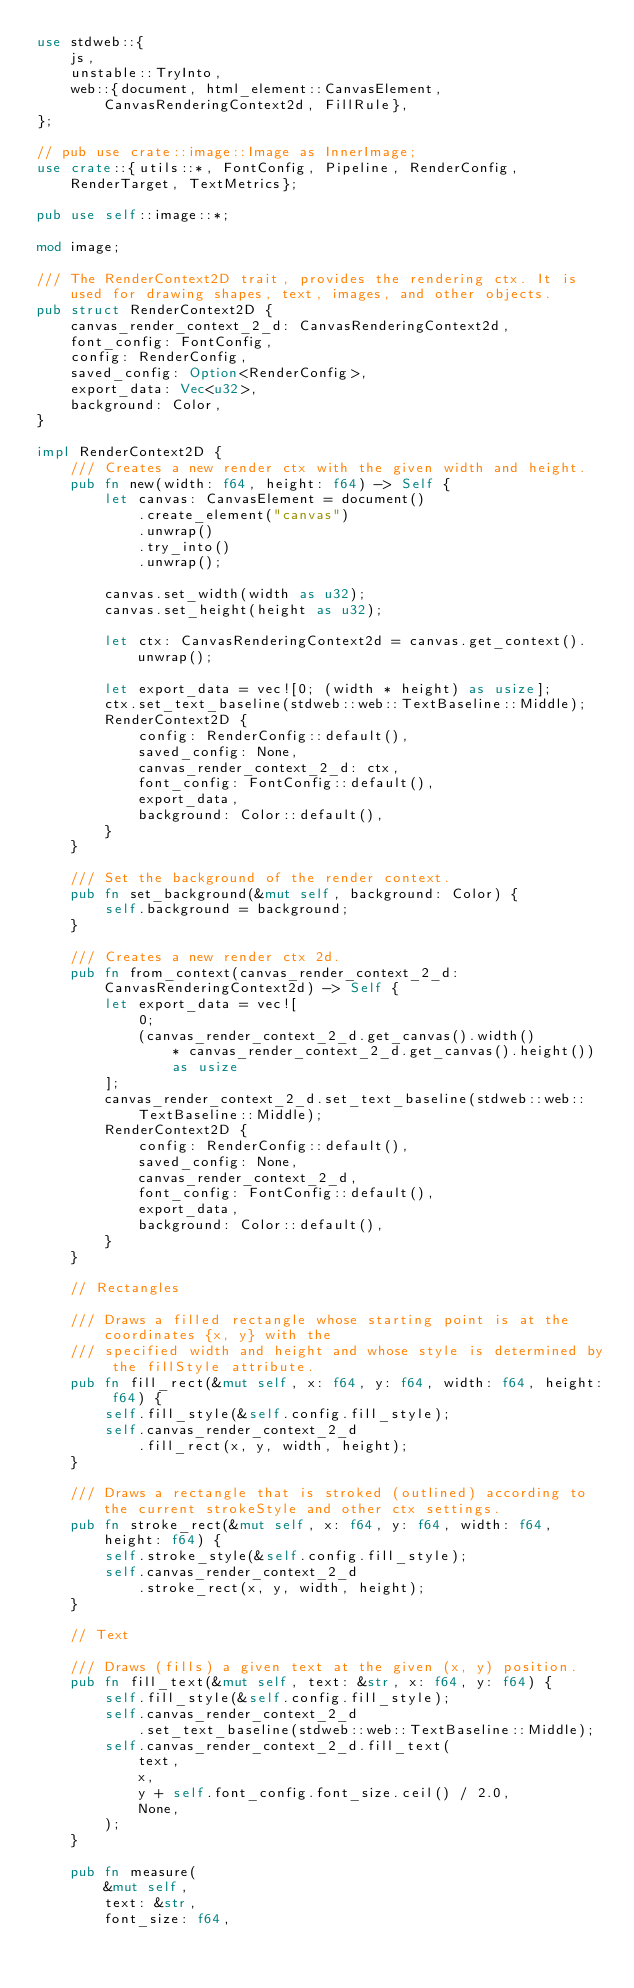Convert code to text. <code><loc_0><loc_0><loc_500><loc_500><_Rust_>use stdweb::{
    js,
    unstable::TryInto,
    web::{document, html_element::CanvasElement, CanvasRenderingContext2d, FillRule},
};

// pub use crate::image::Image as InnerImage;
use crate::{utils::*, FontConfig, Pipeline, RenderConfig, RenderTarget, TextMetrics};

pub use self::image::*;

mod image;

/// The RenderContext2D trait, provides the rendering ctx. It is used for drawing shapes, text, images, and other objects.
pub struct RenderContext2D {
    canvas_render_context_2_d: CanvasRenderingContext2d,
    font_config: FontConfig,
    config: RenderConfig,
    saved_config: Option<RenderConfig>,
    export_data: Vec<u32>,
    background: Color,
}

impl RenderContext2D {
    /// Creates a new render ctx with the given width and height.
    pub fn new(width: f64, height: f64) -> Self {
        let canvas: CanvasElement = document()
            .create_element("canvas")
            .unwrap()
            .try_into()
            .unwrap();

        canvas.set_width(width as u32);
        canvas.set_height(height as u32);

        let ctx: CanvasRenderingContext2d = canvas.get_context().unwrap();

        let export_data = vec![0; (width * height) as usize];
        ctx.set_text_baseline(stdweb::web::TextBaseline::Middle);
        RenderContext2D {
            config: RenderConfig::default(),
            saved_config: None,
            canvas_render_context_2_d: ctx,
            font_config: FontConfig::default(),
            export_data,
            background: Color::default(),
        }
    }

    /// Set the background of the render context.
    pub fn set_background(&mut self, background: Color) {
        self.background = background;
    }

    /// Creates a new render ctx 2d.
    pub fn from_context(canvas_render_context_2_d: CanvasRenderingContext2d) -> Self {
        let export_data = vec![
            0;
            (canvas_render_context_2_d.get_canvas().width()
                * canvas_render_context_2_d.get_canvas().height())
                as usize
        ];
        canvas_render_context_2_d.set_text_baseline(stdweb::web::TextBaseline::Middle);
        RenderContext2D {
            config: RenderConfig::default(),
            saved_config: None,
            canvas_render_context_2_d,
            font_config: FontConfig::default(),
            export_data,
            background: Color::default(),
        }
    }

    // Rectangles

    /// Draws a filled rectangle whose starting point is at the coordinates {x, y} with the
    /// specified width and height and whose style is determined by the fillStyle attribute.
    pub fn fill_rect(&mut self, x: f64, y: f64, width: f64, height: f64) {
        self.fill_style(&self.config.fill_style);
        self.canvas_render_context_2_d
            .fill_rect(x, y, width, height);
    }

    /// Draws a rectangle that is stroked (outlined) according to the current strokeStyle and other ctx settings.
    pub fn stroke_rect(&mut self, x: f64, y: f64, width: f64, height: f64) {
        self.stroke_style(&self.config.fill_style);
        self.canvas_render_context_2_d
            .stroke_rect(x, y, width, height);
    }

    // Text

    /// Draws (fills) a given text at the given (x, y) position.
    pub fn fill_text(&mut self, text: &str, x: f64, y: f64) {
        self.fill_style(&self.config.fill_style);
        self.canvas_render_context_2_d
            .set_text_baseline(stdweb::web::TextBaseline::Middle);
        self.canvas_render_context_2_d.fill_text(
            text,
            x,
            y + self.font_config.font_size.ceil() / 2.0,
            None,
        );
    }

    pub fn measure(
        &mut self,
        text: &str,
        font_size: f64,</code> 